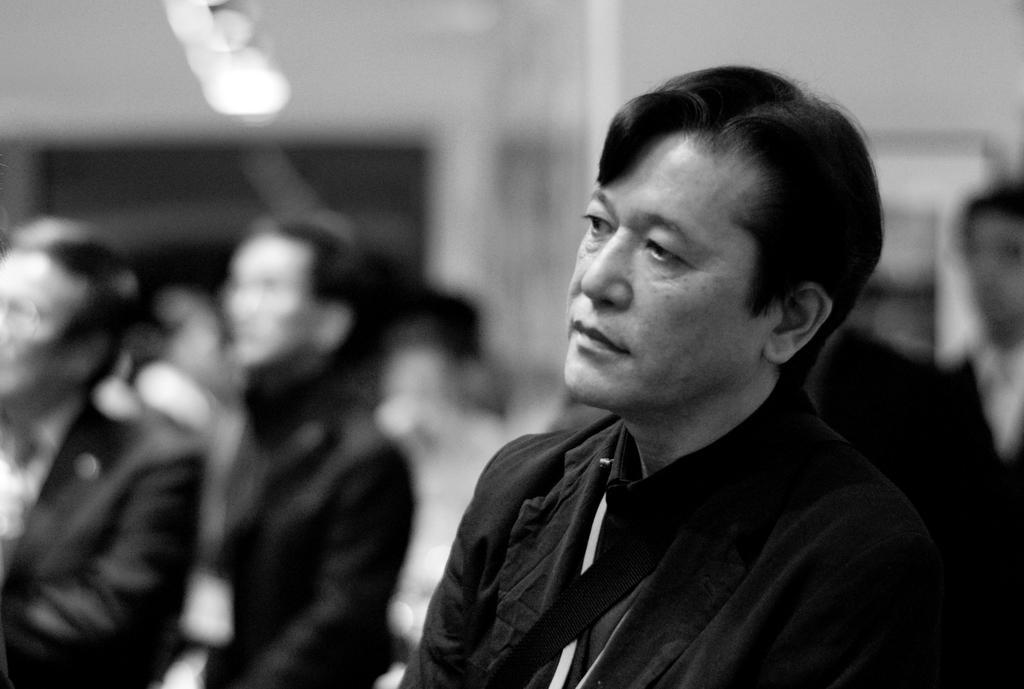How would you summarize this image in a sentence or two? It is a black and white image. In this image we can see the people. We can also see the lights and the background is blurred. 